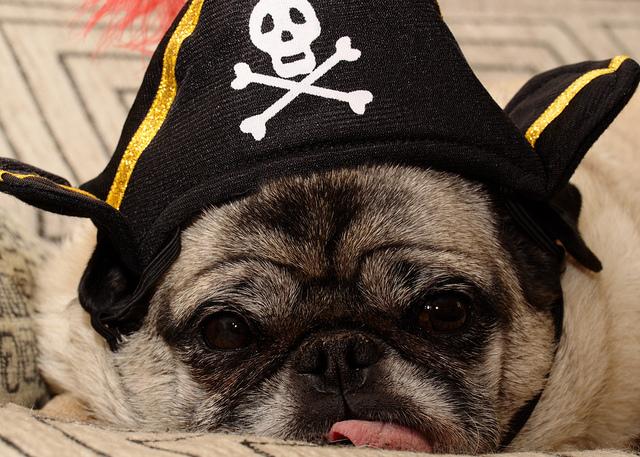What is the dog wearing?
Be succinct. Hat. Can you see the dog's teeth?
Keep it brief. No. What color are the dogs eyes?
Keep it brief. Black. Is this dog sad?
Give a very brief answer. No. Do you think this little pug dog will slip off the top of the couch while he's sleeping?
Give a very brief answer. No. What symbol is on the hat?
Quick response, please. Skull and crossbones. Is the dog moving?
Give a very brief answer. No. What breed of dog is this?
Concise answer only. Pug. 